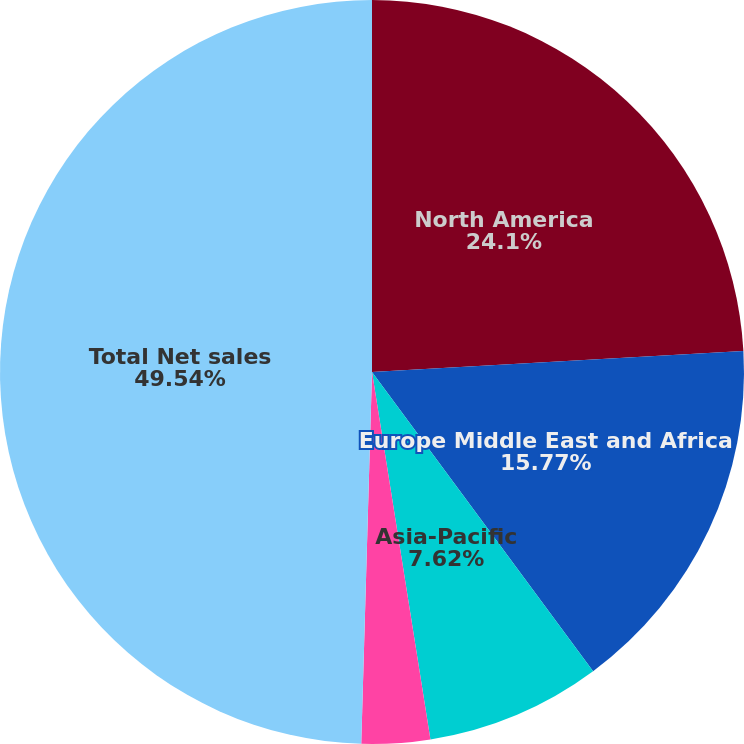Convert chart. <chart><loc_0><loc_0><loc_500><loc_500><pie_chart><fcel>North America<fcel>Europe Middle East and Africa<fcel>Asia-Pacific<fcel>Latin America<fcel>Total Net sales<nl><fcel>24.1%<fcel>15.77%<fcel>7.62%<fcel>2.97%<fcel>49.54%<nl></chart> 